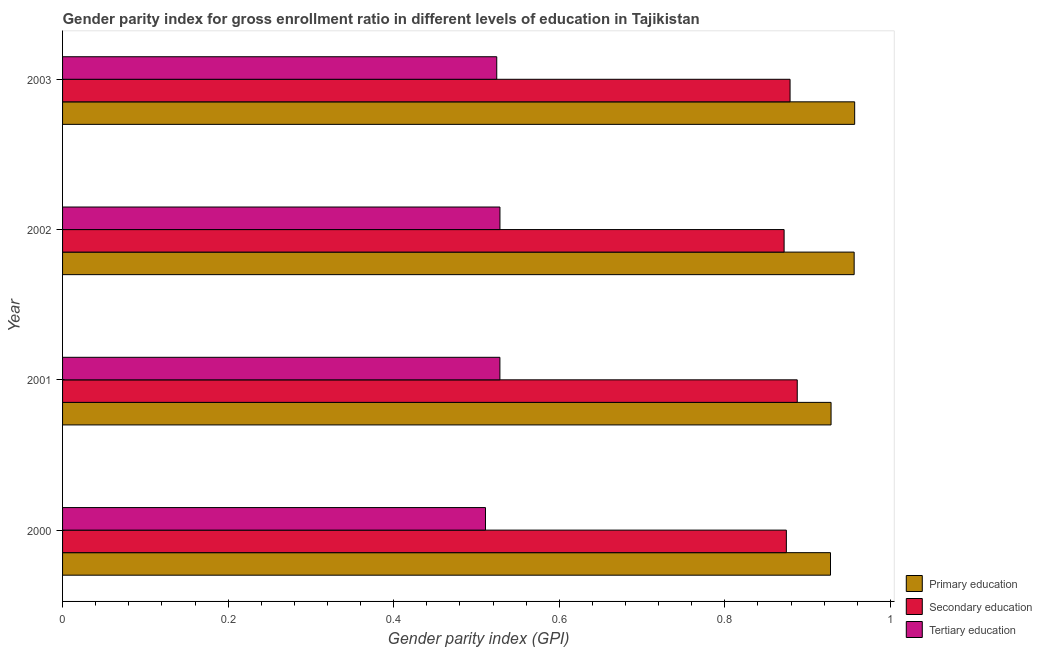Are the number of bars per tick equal to the number of legend labels?
Your response must be concise. Yes. Are the number of bars on each tick of the Y-axis equal?
Your response must be concise. Yes. How many bars are there on the 3rd tick from the top?
Give a very brief answer. 3. What is the label of the 4th group of bars from the top?
Provide a short and direct response. 2000. What is the gender parity index in tertiary education in 2003?
Provide a short and direct response. 0.52. Across all years, what is the maximum gender parity index in tertiary education?
Make the answer very short. 0.53. Across all years, what is the minimum gender parity index in secondary education?
Your response must be concise. 0.87. What is the total gender parity index in secondary education in the graph?
Your response must be concise. 3.51. What is the difference between the gender parity index in secondary education in 2001 and that in 2002?
Provide a succinct answer. 0.02. What is the difference between the gender parity index in primary education in 2001 and the gender parity index in tertiary education in 2002?
Give a very brief answer. 0.4. What is the average gender parity index in primary education per year?
Offer a terse response. 0.94. In the year 2002, what is the difference between the gender parity index in secondary education and gender parity index in primary education?
Ensure brevity in your answer.  -0.09. Is the gender parity index in secondary education in 2000 less than that in 2003?
Provide a short and direct response. Yes. What is the difference between the highest and the second highest gender parity index in primary education?
Provide a short and direct response. 0. What is the difference between the highest and the lowest gender parity index in tertiary education?
Make the answer very short. 0.02. What does the 1st bar from the top in 2002 represents?
Keep it short and to the point. Tertiary education. Is it the case that in every year, the sum of the gender parity index in primary education and gender parity index in secondary education is greater than the gender parity index in tertiary education?
Ensure brevity in your answer.  Yes. Are all the bars in the graph horizontal?
Make the answer very short. Yes. How many years are there in the graph?
Offer a terse response. 4. Does the graph contain any zero values?
Your answer should be compact. No. Does the graph contain grids?
Ensure brevity in your answer.  No. How are the legend labels stacked?
Your answer should be compact. Vertical. What is the title of the graph?
Offer a terse response. Gender parity index for gross enrollment ratio in different levels of education in Tajikistan. What is the label or title of the X-axis?
Your answer should be compact. Gender parity index (GPI). What is the label or title of the Y-axis?
Provide a short and direct response. Year. What is the Gender parity index (GPI) in Primary education in 2000?
Your response must be concise. 0.93. What is the Gender parity index (GPI) of Secondary education in 2000?
Give a very brief answer. 0.87. What is the Gender parity index (GPI) in Tertiary education in 2000?
Give a very brief answer. 0.51. What is the Gender parity index (GPI) in Primary education in 2001?
Give a very brief answer. 0.93. What is the Gender parity index (GPI) in Secondary education in 2001?
Ensure brevity in your answer.  0.89. What is the Gender parity index (GPI) in Tertiary education in 2001?
Provide a succinct answer. 0.53. What is the Gender parity index (GPI) in Primary education in 2002?
Your response must be concise. 0.96. What is the Gender parity index (GPI) of Secondary education in 2002?
Offer a very short reply. 0.87. What is the Gender parity index (GPI) in Tertiary education in 2002?
Ensure brevity in your answer.  0.53. What is the Gender parity index (GPI) of Primary education in 2003?
Provide a succinct answer. 0.96. What is the Gender parity index (GPI) in Secondary education in 2003?
Offer a very short reply. 0.88. What is the Gender parity index (GPI) in Tertiary education in 2003?
Give a very brief answer. 0.52. Across all years, what is the maximum Gender parity index (GPI) of Primary education?
Offer a very short reply. 0.96. Across all years, what is the maximum Gender parity index (GPI) in Secondary education?
Provide a succinct answer. 0.89. Across all years, what is the maximum Gender parity index (GPI) in Tertiary education?
Offer a terse response. 0.53. Across all years, what is the minimum Gender parity index (GPI) in Primary education?
Offer a very short reply. 0.93. Across all years, what is the minimum Gender parity index (GPI) in Secondary education?
Offer a very short reply. 0.87. Across all years, what is the minimum Gender parity index (GPI) of Tertiary education?
Ensure brevity in your answer.  0.51. What is the total Gender parity index (GPI) in Primary education in the graph?
Provide a short and direct response. 3.77. What is the total Gender parity index (GPI) of Secondary education in the graph?
Offer a terse response. 3.51. What is the total Gender parity index (GPI) of Tertiary education in the graph?
Provide a short and direct response. 2.09. What is the difference between the Gender parity index (GPI) in Primary education in 2000 and that in 2001?
Your response must be concise. -0. What is the difference between the Gender parity index (GPI) of Secondary education in 2000 and that in 2001?
Ensure brevity in your answer.  -0.01. What is the difference between the Gender parity index (GPI) of Tertiary education in 2000 and that in 2001?
Offer a terse response. -0.02. What is the difference between the Gender parity index (GPI) in Primary education in 2000 and that in 2002?
Provide a succinct answer. -0.03. What is the difference between the Gender parity index (GPI) in Secondary education in 2000 and that in 2002?
Offer a terse response. 0. What is the difference between the Gender parity index (GPI) of Tertiary education in 2000 and that in 2002?
Ensure brevity in your answer.  -0.02. What is the difference between the Gender parity index (GPI) of Primary education in 2000 and that in 2003?
Make the answer very short. -0.03. What is the difference between the Gender parity index (GPI) in Secondary education in 2000 and that in 2003?
Your response must be concise. -0. What is the difference between the Gender parity index (GPI) of Tertiary education in 2000 and that in 2003?
Your answer should be very brief. -0.01. What is the difference between the Gender parity index (GPI) of Primary education in 2001 and that in 2002?
Offer a very short reply. -0.03. What is the difference between the Gender parity index (GPI) of Secondary education in 2001 and that in 2002?
Offer a very short reply. 0.02. What is the difference between the Gender parity index (GPI) of Tertiary education in 2001 and that in 2002?
Offer a very short reply. -0. What is the difference between the Gender parity index (GPI) of Primary education in 2001 and that in 2003?
Provide a short and direct response. -0.03. What is the difference between the Gender parity index (GPI) of Secondary education in 2001 and that in 2003?
Your answer should be very brief. 0.01. What is the difference between the Gender parity index (GPI) of Tertiary education in 2001 and that in 2003?
Keep it short and to the point. 0. What is the difference between the Gender parity index (GPI) in Primary education in 2002 and that in 2003?
Ensure brevity in your answer.  -0. What is the difference between the Gender parity index (GPI) of Secondary education in 2002 and that in 2003?
Your response must be concise. -0.01. What is the difference between the Gender parity index (GPI) in Tertiary education in 2002 and that in 2003?
Make the answer very short. 0. What is the difference between the Gender parity index (GPI) of Primary education in 2000 and the Gender parity index (GPI) of Secondary education in 2001?
Offer a very short reply. 0.04. What is the difference between the Gender parity index (GPI) of Primary education in 2000 and the Gender parity index (GPI) of Tertiary education in 2001?
Your response must be concise. 0.4. What is the difference between the Gender parity index (GPI) of Secondary education in 2000 and the Gender parity index (GPI) of Tertiary education in 2001?
Your response must be concise. 0.35. What is the difference between the Gender parity index (GPI) of Primary education in 2000 and the Gender parity index (GPI) of Secondary education in 2002?
Offer a very short reply. 0.06. What is the difference between the Gender parity index (GPI) in Primary education in 2000 and the Gender parity index (GPI) in Tertiary education in 2002?
Provide a succinct answer. 0.4. What is the difference between the Gender parity index (GPI) in Secondary education in 2000 and the Gender parity index (GPI) in Tertiary education in 2002?
Offer a very short reply. 0.35. What is the difference between the Gender parity index (GPI) in Primary education in 2000 and the Gender parity index (GPI) in Secondary education in 2003?
Your answer should be compact. 0.05. What is the difference between the Gender parity index (GPI) in Primary education in 2000 and the Gender parity index (GPI) in Tertiary education in 2003?
Give a very brief answer. 0.4. What is the difference between the Gender parity index (GPI) of Secondary education in 2000 and the Gender parity index (GPI) of Tertiary education in 2003?
Offer a terse response. 0.35. What is the difference between the Gender parity index (GPI) of Primary education in 2001 and the Gender parity index (GPI) of Secondary education in 2002?
Offer a terse response. 0.06. What is the difference between the Gender parity index (GPI) in Primary education in 2001 and the Gender parity index (GPI) in Tertiary education in 2002?
Keep it short and to the point. 0.4. What is the difference between the Gender parity index (GPI) in Secondary education in 2001 and the Gender parity index (GPI) in Tertiary education in 2002?
Provide a short and direct response. 0.36. What is the difference between the Gender parity index (GPI) of Primary education in 2001 and the Gender parity index (GPI) of Secondary education in 2003?
Your response must be concise. 0.05. What is the difference between the Gender parity index (GPI) in Primary education in 2001 and the Gender parity index (GPI) in Tertiary education in 2003?
Provide a short and direct response. 0.4. What is the difference between the Gender parity index (GPI) in Secondary education in 2001 and the Gender parity index (GPI) in Tertiary education in 2003?
Ensure brevity in your answer.  0.36. What is the difference between the Gender parity index (GPI) in Primary education in 2002 and the Gender parity index (GPI) in Secondary education in 2003?
Your answer should be very brief. 0.08. What is the difference between the Gender parity index (GPI) in Primary education in 2002 and the Gender parity index (GPI) in Tertiary education in 2003?
Your answer should be very brief. 0.43. What is the difference between the Gender parity index (GPI) of Secondary education in 2002 and the Gender parity index (GPI) of Tertiary education in 2003?
Your response must be concise. 0.35. What is the average Gender parity index (GPI) of Primary education per year?
Ensure brevity in your answer.  0.94. What is the average Gender parity index (GPI) of Secondary education per year?
Offer a terse response. 0.88. What is the average Gender parity index (GPI) of Tertiary education per year?
Give a very brief answer. 0.52. In the year 2000, what is the difference between the Gender parity index (GPI) of Primary education and Gender parity index (GPI) of Secondary education?
Offer a very short reply. 0.05. In the year 2000, what is the difference between the Gender parity index (GPI) of Primary education and Gender parity index (GPI) of Tertiary education?
Your response must be concise. 0.42. In the year 2000, what is the difference between the Gender parity index (GPI) in Secondary education and Gender parity index (GPI) in Tertiary education?
Your answer should be compact. 0.36. In the year 2001, what is the difference between the Gender parity index (GPI) of Primary education and Gender parity index (GPI) of Secondary education?
Your answer should be very brief. 0.04. In the year 2001, what is the difference between the Gender parity index (GPI) of Primary education and Gender parity index (GPI) of Tertiary education?
Offer a very short reply. 0.4. In the year 2001, what is the difference between the Gender parity index (GPI) of Secondary education and Gender parity index (GPI) of Tertiary education?
Your answer should be very brief. 0.36. In the year 2002, what is the difference between the Gender parity index (GPI) of Primary education and Gender parity index (GPI) of Secondary education?
Give a very brief answer. 0.08. In the year 2002, what is the difference between the Gender parity index (GPI) of Primary education and Gender parity index (GPI) of Tertiary education?
Offer a very short reply. 0.43. In the year 2002, what is the difference between the Gender parity index (GPI) in Secondary education and Gender parity index (GPI) in Tertiary education?
Make the answer very short. 0.34. In the year 2003, what is the difference between the Gender parity index (GPI) of Primary education and Gender parity index (GPI) of Secondary education?
Offer a very short reply. 0.08. In the year 2003, what is the difference between the Gender parity index (GPI) of Primary education and Gender parity index (GPI) of Tertiary education?
Offer a very short reply. 0.43. In the year 2003, what is the difference between the Gender parity index (GPI) of Secondary education and Gender parity index (GPI) of Tertiary education?
Offer a terse response. 0.35. What is the ratio of the Gender parity index (GPI) in Secondary education in 2000 to that in 2001?
Make the answer very short. 0.99. What is the ratio of the Gender parity index (GPI) in Tertiary education in 2000 to that in 2001?
Provide a succinct answer. 0.97. What is the ratio of the Gender parity index (GPI) in Primary education in 2000 to that in 2002?
Your response must be concise. 0.97. What is the ratio of the Gender parity index (GPI) in Secondary education in 2000 to that in 2002?
Ensure brevity in your answer.  1. What is the ratio of the Gender parity index (GPI) in Tertiary education in 2000 to that in 2002?
Provide a short and direct response. 0.97. What is the ratio of the Gender parity index (GPI) of Primary education in 2000 to that in 2003?
Give a very brief answer. 0.97. What is the ratio of the Gender parity index (GPI) in Secondary education in 2000 to that in 2003?
Provide a succinct answer. 0.99. What is the ratio of the Gender parity index (GPI) of Tertiary education in 2000 to that in 2003?
Provide a short and direct response. 0.97. What is the ratio of the Gender parity index (GPI) of Primary education in 2001 to that in 2002?
Give a very brief answer. 0.97. What is the ratio of the Gender parity index (GPI) of Secondary education in 2001 to that in 2002?
Give a very brief answer. 1.02. What is the ratio of the Gender parity index (GPI) of Primary education in 2001 to that in 2003?
Offer a terse response. 0.97. What is the ratio of the Gender parity index (GPI) of Secondary education in 2001 to that in 2003?
Keep it short and to the point. 1.01. What is the ratio of the Gender parity index (GPI) of Primary education in 2002 to that in 2003?
Make the answer very short. 1. What is the ratio of the Gender parity index (GPI) of Secondary education in 2002 to that in 2003?
Offer a very short reply. 0.99. What is the ratio of the Gender parity index (GPI) of Tertiary education in 2002 to that in 2003?
Offer a terse response. 1.01. What is the difference between the highest and the second highest Gender parity index (GPI) of Primary education?
Provide a succinct answer. 0. What is the difference between the highest and the second highest Gender parity index (GPI) in Secondary education?
Provide a succinct answer. 0.01. What is the difference between the highest and the lowest Gender parity index (GPI) in Primary education?
Give a very brief answer. 0.03. What is the difference between the highest and the lowest Gender parity index (GPI) in Secondary education?
Your answer should be very brief. 0.02. What is the difference between the highest and the lowest Gender parity index (GPI) of Tertiary education?
Provide a short and direct response. 0.02. 